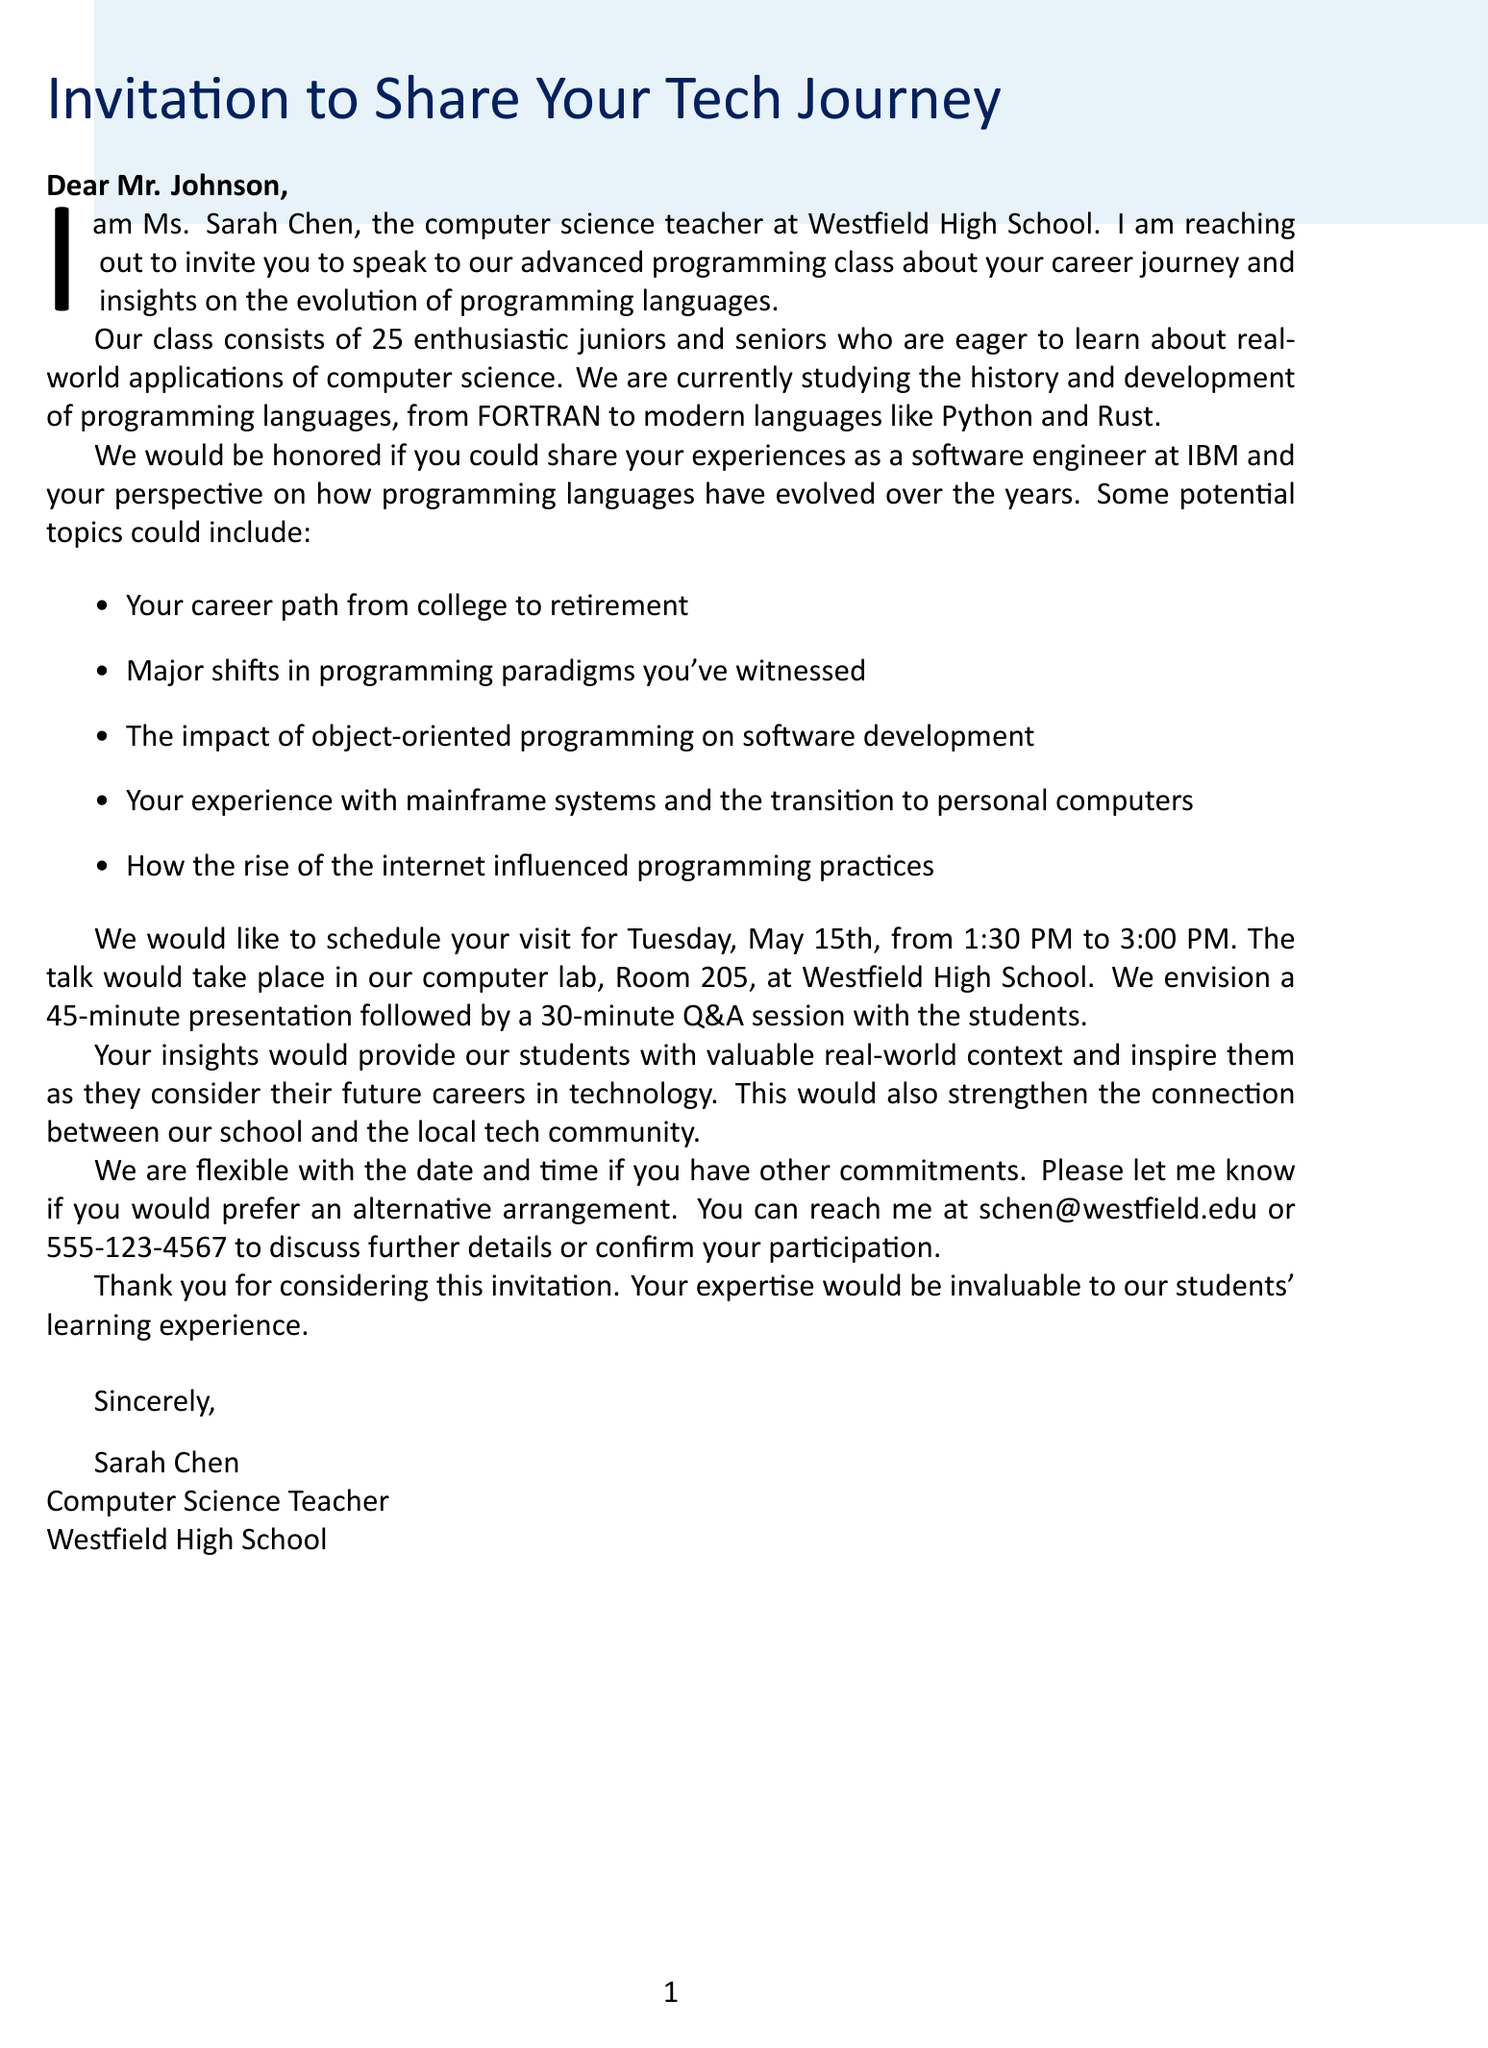What is the teacher's name? The document specifies the teacher's name as the sender of the letter.
Answer: Ms. Sarah Chen Who is the letter addressed to? The salutation identifies the recipient of the letter.
Answer: Mr. Johnson What is the proposed date for the visit? The document states the specific date suggested for the visit in the logistical details.
Answer: Tuesday, May 15th How long is the proposed presentation? The letter outlines the expected length of the presentation within the logistical details section.
Answer: 45 minutes What specific programming languages are mentioned as part of the current topic? The current topic mentioned in the letter includes certain programming languages.
Answer: FORTRAN, Python Which company did the speaker work for? The letter provides background about the speaker, including his former employer.
Answer: IBM What is one potential topic for the speaker's talk? The letter lists several potential topics that the speaker could discuss.
Answer: Major shifts in programming paradigms you've witnessed What is the expected format of the session? The document describes how the talk is structured in terms of presentation and Q&A.
Answer: 45-minute presentation followed by a 30-minute Q&A session Why would the insights be valuable for students? The letter explains the anticipated impact of the speaker’s insights on the students.
Answer: Valuable real-world context 